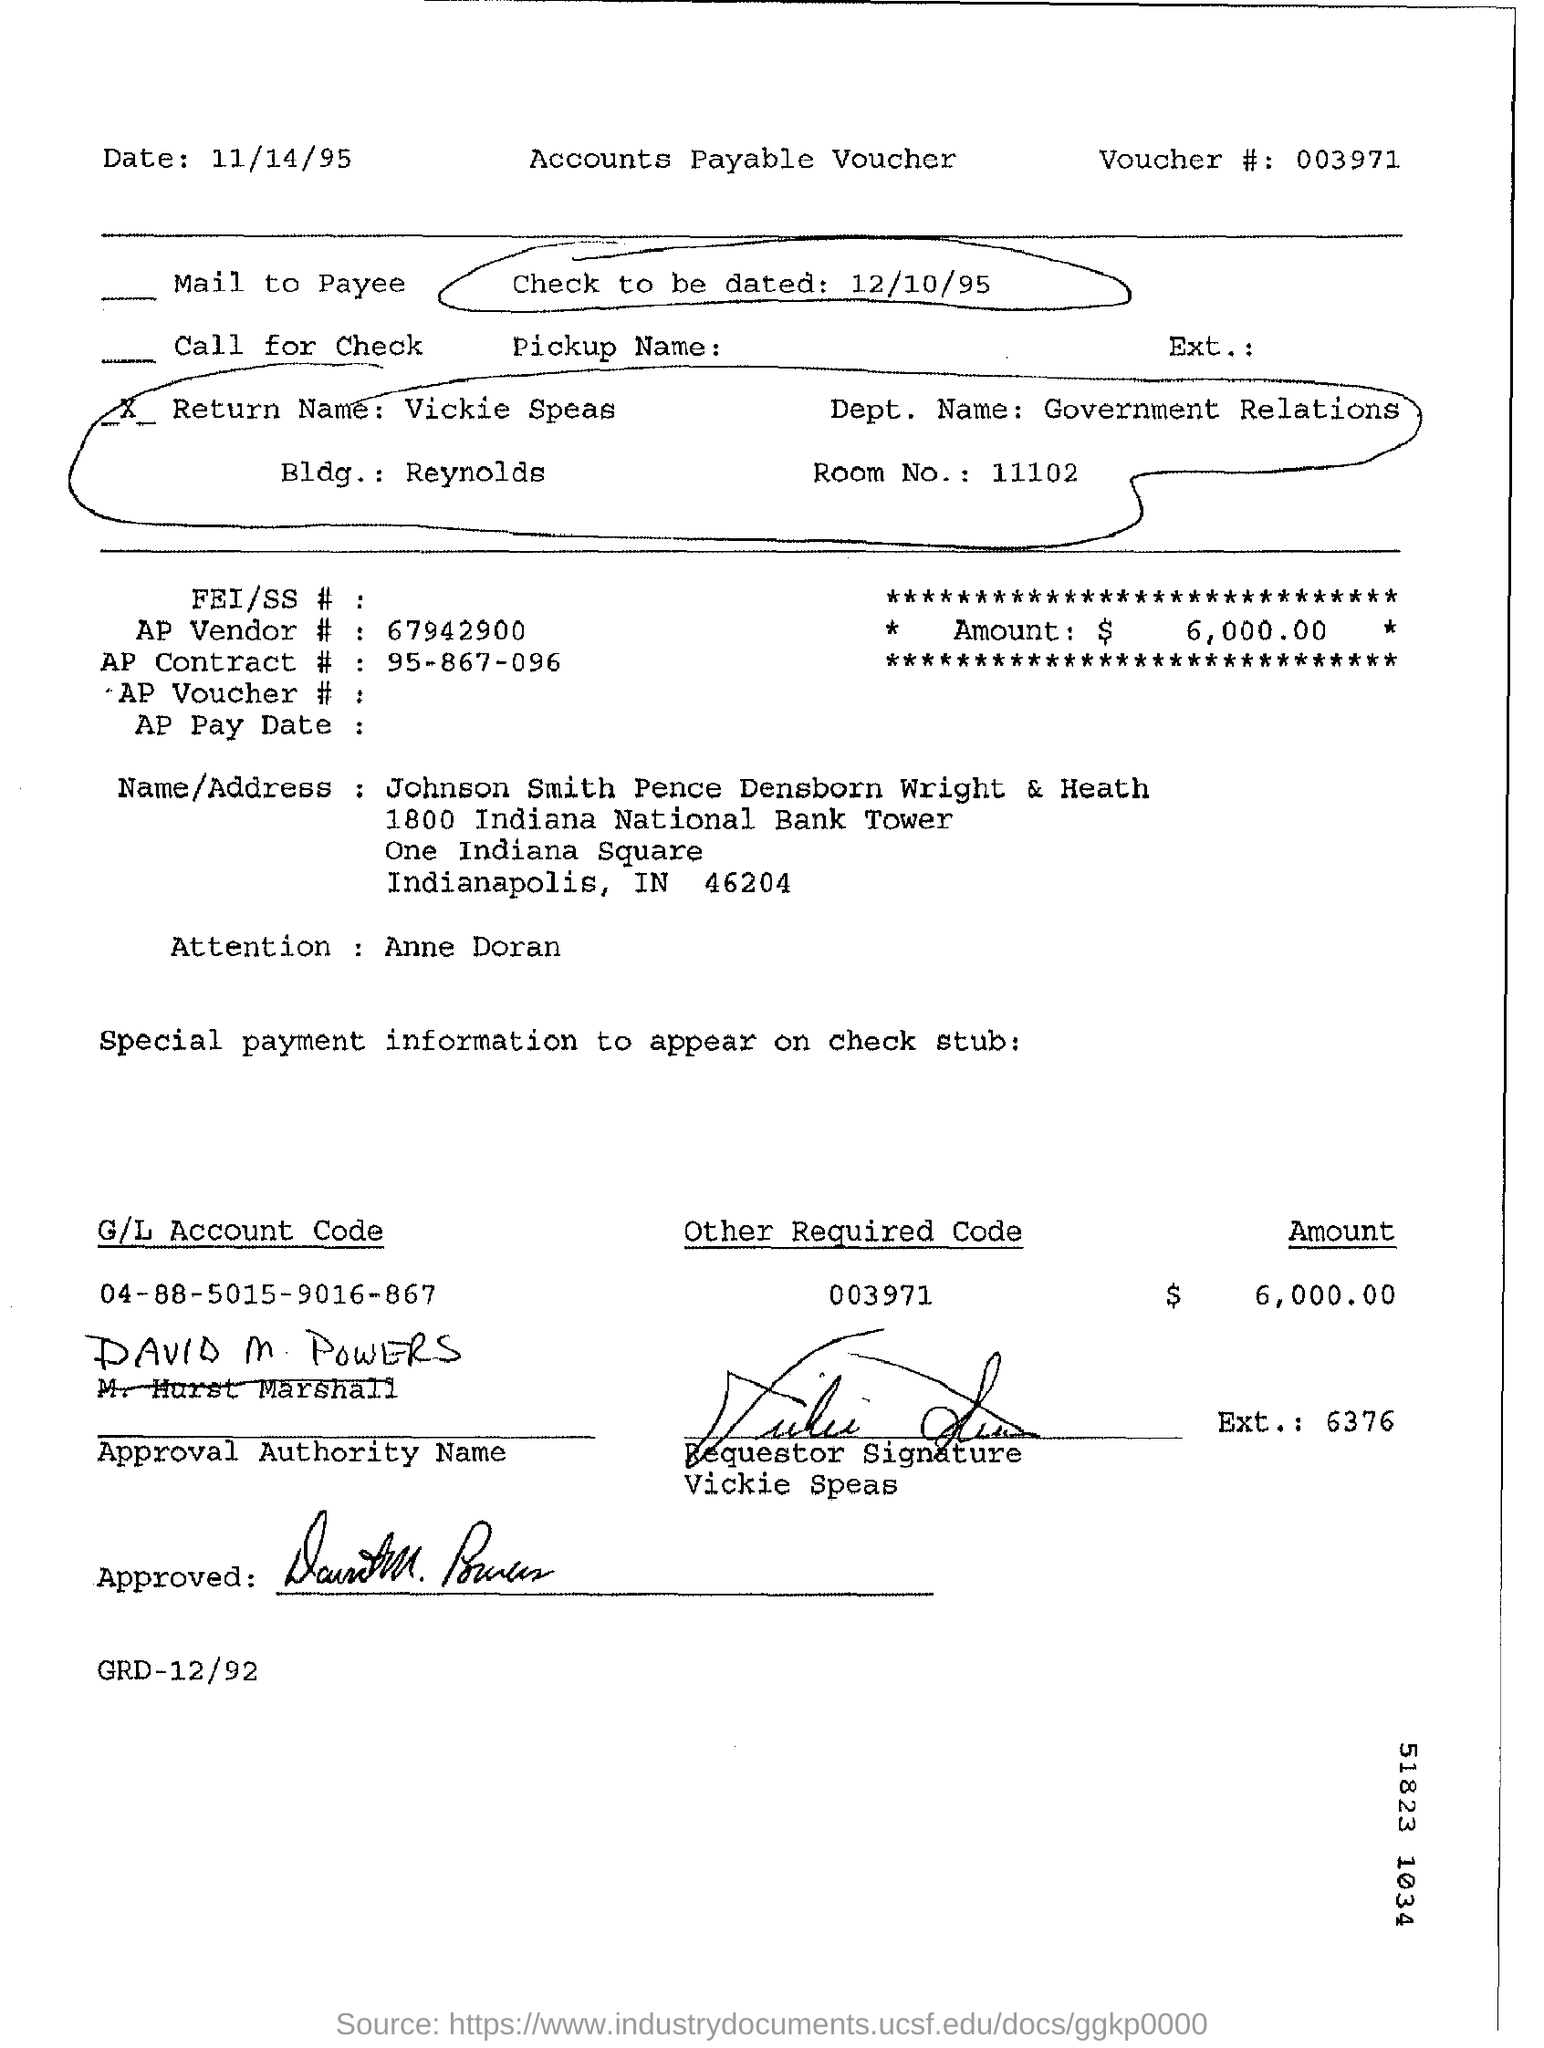When is the check to be dated?
Make the answer very short. 12/10/95. What is the department name provided?
Your answer should be very brief. Government relations. What is the voucher no given in the form?
Provide a succinct answer. 003971. What is the G/L Account Code mentioned?
Offer a very short reply. 04-88-5015-9016-867. 